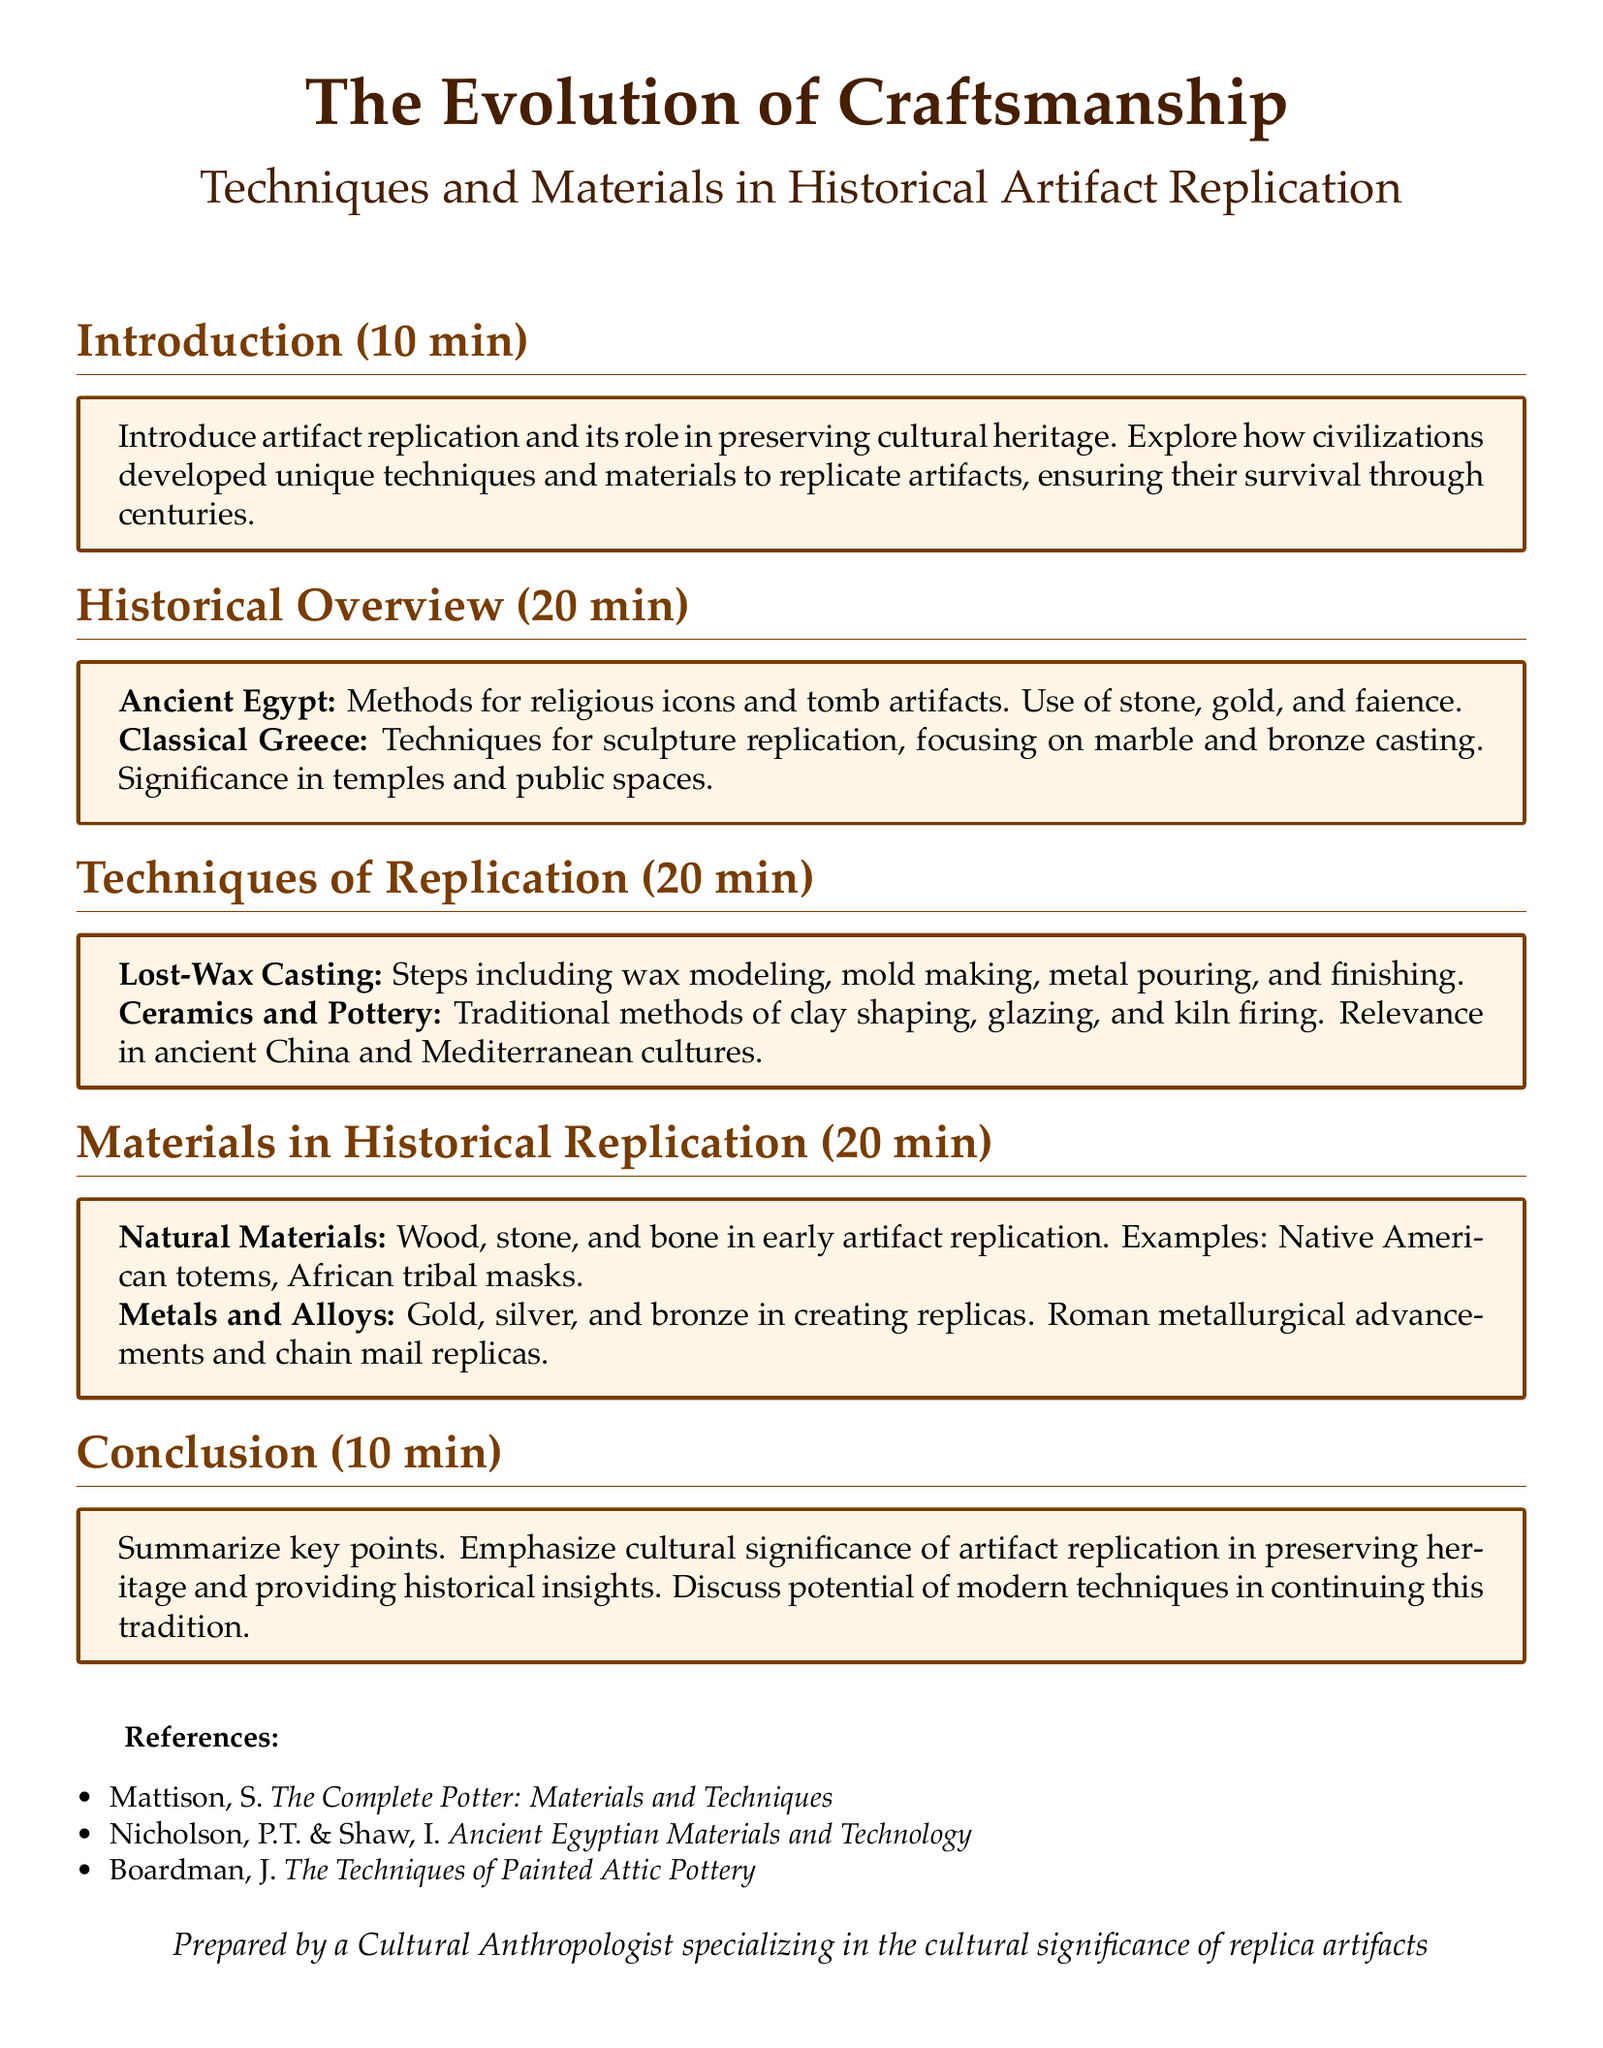what is the title of the lesson plan? The title clearly states the focus of the lesson plan, which is on craftsmanship in historical artifact replication.
Answer: The Evolution of Craftsmanship how long is the Historical Overview section? The document specifies the duration allocated for this section, indicating its importance in the lesson plan.
Answer: 20 min what technique does the Lost-Wax Casting involve? The document outlines this specific technique and its steps, indicating its significance in historical replication.
Answer: Wax modeling which materials were used in Ancient Egypt for artifact replication? The document lists specific materials that were important in Ancient Egyptian artifacts, signaling their cultural value.
Answer: Stone, gold, faience how are traditional methods of clay shaping referred to? The document provides terminology for the techniques used in ceramics and pottery, indicating their historical context.
Answer: Ceramics and Pottery what is the emphasized role of artifact replication according to the conclusion? The conclusion highlights the importance of artifact replication in cultural heritage preservation, summarizing the key points discussed.
Answer: Preserving heritage who is the intended audience for the lesson plan? The document indicates the professional background of the author, suggesting the target audience for this educational content.
Answer: Cultural Anthropologist what advancement is noted in the document for metals in replication? The document refers to specific advancements that allowed for improved replication techniques, showcasing cultural developments.
Answer: Roman metallurgical advancements 